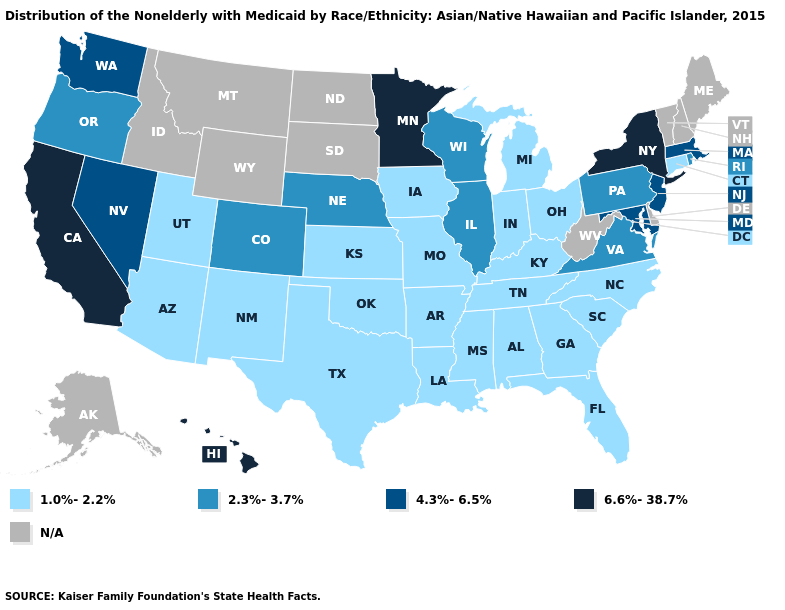Among the states that border Minnesota , which have the lowest value?
Short answer required. Iowa. Which states have the highest value in the USA?
Be succinct. California, Hawaii, Minnesota, New York. Which states have the highest value in the USA?
Concise answer only. California, Hawaii, Minnesota, New York. How many symbols are there in the legend?
Write a very short answer. 5. What is the value of North Carolina?
Short answer required. 1.0%-2.2%. What is the value of Montana?
Give a very brief answer. N/A. Is the legend a continuous bar?
Keep it brief. No. What is the value of Arkansas?
Answer briefly. 1.0%-2.2%. Among the states that border Wisconsin , does Michigan have the lowest value?
Keep it brief. Yes. Does Tennessee have the highest value in the USA?
Write a very short answer. No. Name the states that have a value in the range N/A?
Keep it brief. Alaska, Delaware, Idaho, Maine, Montana, New Hampshire, North Dakota, South Dakota, Vermont, West Virginia, Wyoming. What is the highest value in the USA?
Give a very brief answer. 6.6%-38.7%. Among the states that border Arkansas , which have the lowest value?
Short answer required. Louisiana, Mississippi, Missouri, Oklahoma, Tennessee, Texas. 